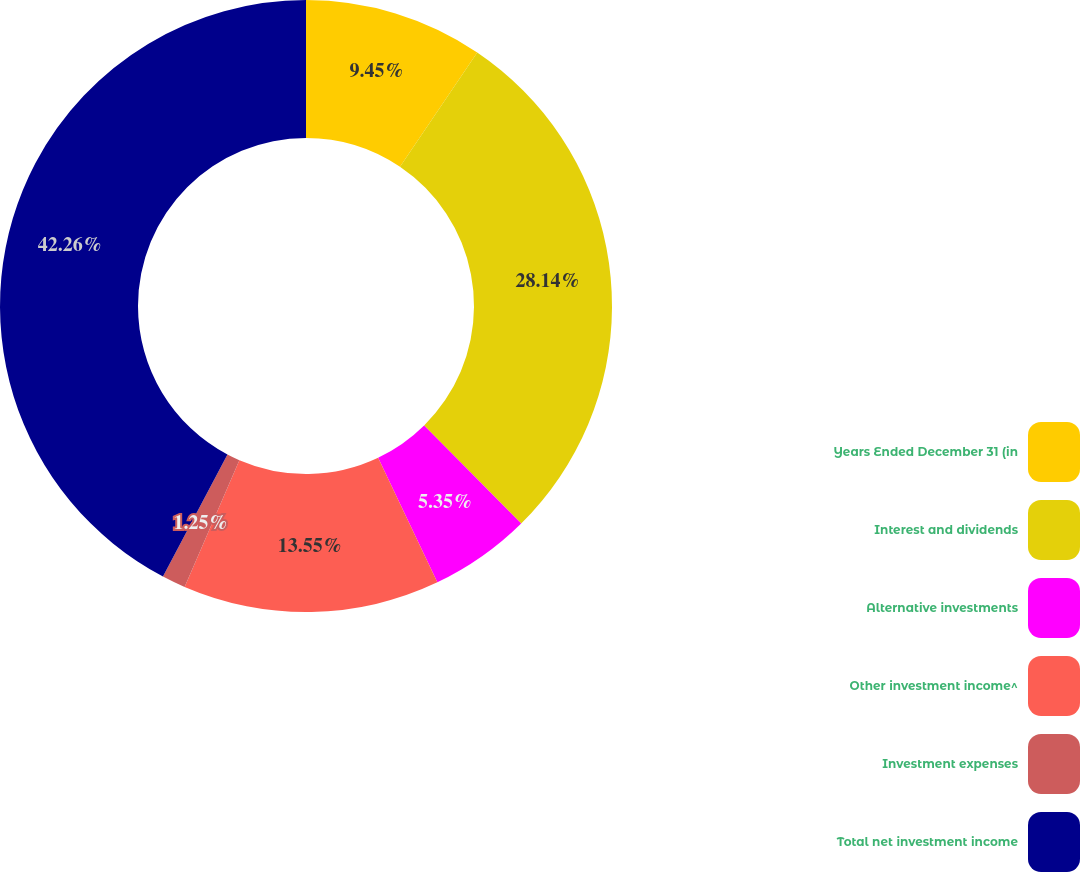Convert chart to OTSL. <chart><loc_0><loc_0><loc_500><loc_500><pie_chart><fcel>Years Ended December 31 (in<fcel>Interest and dividends<fcel>Alternative investments<fcel>Other investment income^<fcel>Investment expenses<fcel>Total net investment income<nl><fcel>9.45%<fcel>28.13%<fcel>5.35%<fcel>13.55%<fcel>1.25%<fcel>42.25%<nl></chart> 